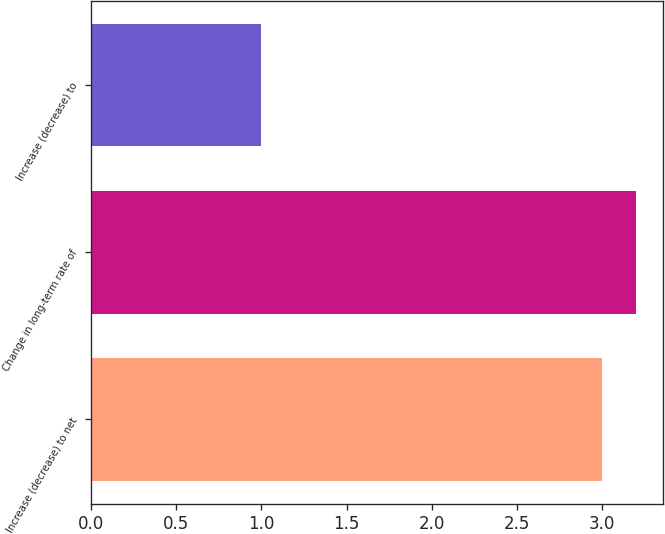<chart> <loc_0><loc_0><loc_500><loc_500><bar_chart><fcel>Increase (decrease) to net<fcel>Change in long-term rate of<fcel>Increase (decrease) to<nl><fcel>3<fcel>3.2<fcel>1<nl></chart> 